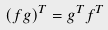Convert formula to latex. <formula><loc_0><loc_0><loc_500><loc_500>( f g ) ^ { T } = g ^ { T } f ^ { T }</formula> 